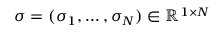<formula> <loc_0><loc_0><loc_500><loc_500>\sigma = ( \sigma _ { 1 } , \dots , \sigma _ { N } ) \in \mathbb { R } ^ { 1 \times N }</formula> 